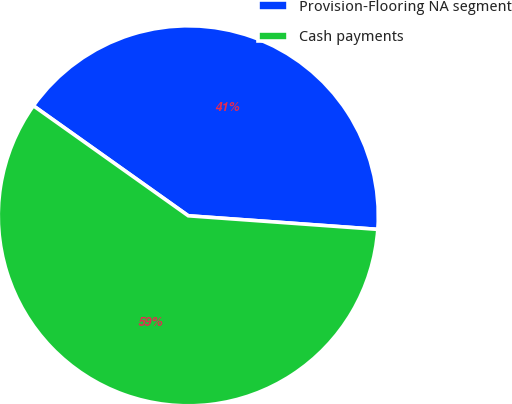<chart> <loc_0><loc_0><loc_500><loc_500><pie_chart><fcel>Provision-Flooring NA segment<fcel>Cash payments<nl><fcel>41.31%<fcel>58.69%<nl></chart> 